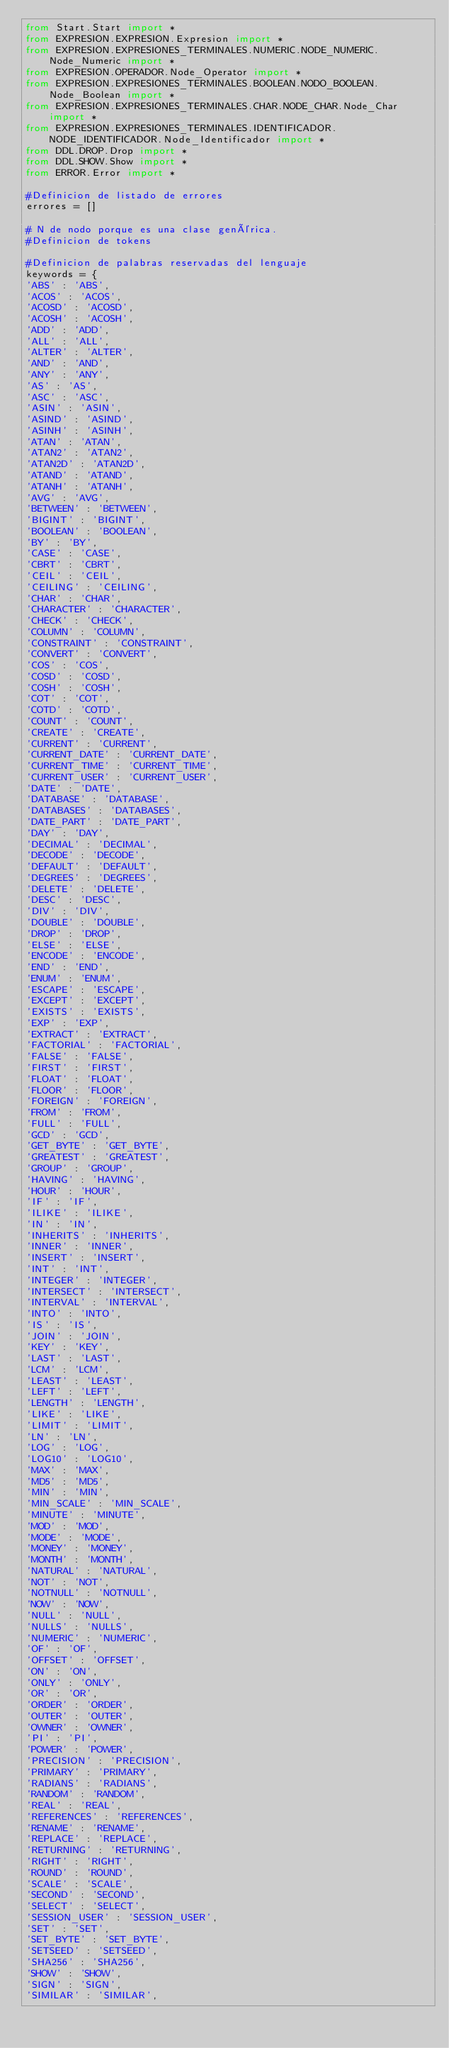Convert code to text. <code><loc_0><loc_0><loc_500><loc_500><_Python_>from Start.Start import * 
from EXPRESION.EXPRESION.Expresion import *
from EXPRESION.EXPRESIONES_TERMINALES.NUMERIC.NODE_NUMERIC.Node_Numeric import *
from EXPRESION.OPERADOR.Node_Operator import *
from EXPRESION.EXPRESIONES_TERMINALES.BOOLEAN.NODO_BOOLEAN.Node_Boolean import *
from EXPRESION.EXPRESIONES_TERMINALES.CHAR.NODE_CHAR.Node_Char import *
from EXPRESION.EXPRESIONES_TERMINALES.IDENTIFICADOR.NODE_IDENTIFICADOR.Node_Identificador import *
from DDL.DROP.Drop import *
from DDL.SHOW.Show import *
from ERROR.Error import *

#Definicion de listado de errores
errores = []

# N de nodo porque es una clase genérica.
#Definicion de tokens

#Definicion de palabras reservadas del lenguaje
keywords = {
'ABS' : 'ABS',
'ACOS' : 'ACOS',
'ACOSD' : 'ACOSD',
'ACOSH' : 'ACOSH',
'ADD' : 'ADD',
'ALL' : 'ALL',
'ALTER' : 'ALTER',
'AND' : 'AND',
'ANY' : 'ANY',
'AS' : 'AS',
'ASC' : 'ASC',
'ASIN' : 'ASIN',
'ASIND' : 'ASIND',
'ASINH' : 'ASINH',
'ATAN' : 'ATAN',
'ATAN2' : 'ATAN2',
'ATAN2D' : 'ATAN2D',
'ATAND' : 'ATAND',
'ATANH' : 'ATANH',
'AVG' : 'AVG',
'BETWEEN' : 'BETWEEN',
'BIGINT' : 'BIGINT',
'BOOLEAN' : 'BOOLEAN',
'BY' : 'BY',
'CASE' : 'CASE',
'CBRT' : 'CBRT',
'CEIL' : 'CEIL',
'CEILING' : 'CEILING',
'CHAR' : 'CHAR',
'CHARACTER' : 'CHARACTER',
'CHECK' : 'CHECK',
'COLUMN' : 'COLUMN',
'CONSTRAINT' : 'CONSTRAINT',
'CONVERT' : 'CONVERT',
'COS' : 'COS',
'COSD' : 'COSD',
'COSH' : 'COSH',
'COT' : 'COT',
'COTD' : 'COTD',
'COUNT' : 'COUNT',
'CREATE' : 'CREATE',
'CURRENT' : 'CURRENT',
'CURRENT_DATE' : 'CURRENT_DATE',
'CURRENT_TIME' : 'CURRENT_TIME',
'CURRENT_USER' : 'CURRENT_USER',
'DATE' : 'DATE',
'DATABASE' : 'DATABASE',
'DATABASES' : 'DATABASES',
'DATE_PART' : 'DATE_PART',
'DAY' : 'DAY',
'DECIMAL' : 'DECIMAL',
'DECODE' : 'DECODE',
'DEFAULT' : 'DEFAULT',
'DEGREES' : 'DEGREES',
'DELETE' : 'DELETE',
'DESC' : 'DESC',
'DIV' : 'DIV',
'DOUBLE' : 'DOUBLE',
'DROP' : 'DROP',
'ELSE' : 'ELSE',
'ENCODE' : 'ENCODE',
'END' : 'END',
'ENUM' : 'ENUM',
'ESCAPE' : 'ESCAPE',
'EXCEPT' : 'EXCEPT',
'EXISTS' : 'EXISTS',
'EXP' : 'EXP',
'EXTRACT' : 'EXTRACT',
'FACTORIAL' : 'FACTORIAL',
'FALSE' : 'FALSE',
'FIRST' : 'FIRST',
'FLOAT' : 'FLOAT',
'FLOOR' : 'FLOOR',
'FOREIGN' : 'FOREIGN',
'FROM' : 'FROM',
'FULL' : 'FULL',
'GCD' : 'GCD',
'GET_BYTE' : 'GET_BYTE',
'GREATEST' : 'GREATEST',
'GROUP' : 'GROUP',
'HAVING' : 'HAVING',
'HOUR' : 'HOUR',
'IF' : 'IF',
'ILIKE' : 'ILIKE',
'IN' : 'IN',
'INHERITS' : 'INHERITS',
'INNER' : 'INNER',
'INSERT' : 'INSERT',
'INT' : 'INT',
'INTEGER' : 'INTEGER',
'INTERSECT' : 'INTERSECT',
'INTERVAL' : 'INTERVAL',
'INTO' : 'INTO',
'IS' : 'IS',
'JOIN' : 'JOIN',
'KEY' : 'KEY',
'LAST' : 'LAST',
'LCM' : 'LCM',
'LEAST' : 'LEAST',
'LEFT' : 'LEFT',
'LENGTH' : 'LENGTH',
'LIKE' : 'LIKE',
'LIMIT' : 'LIMIT',
'LN' : 'LN',
'LOG' : 'LOG',
'LOG10' : 'LOG10',
'MAX' : 'MAX',
'MD5' : 'MD5',
'MIN' : 'MIN',
'MIN_SCALE' : 'MIN_SCALE',
'MINUTE' : 'MINUTE',
'MOD' : 'MOD',
'MODE' : 'MODE',
'MONEY' : 'MONEY',
'MONTH' : 'MONTH',
'NATURAL' : 'NATURAL',
'NOT' : 'NOT',
'NOTNULL' : 'NOTNULL',
'NOW' : 'NOW',
'NULL' : 'NULL',
'NULLS' : 'NULLS',
'NUMERIC' : 'NUMERIC',
'OF' : 'OF',
'OFFSET' : 'OFFSET',
'ON' : 'ON',
'ONLY' : 'ONLY',
'OR' : 'OR',
'ORDER' : 'ORDER',
'OUTER' : 'OUTER',
'OWNER' : 'OWNER',
'PI' : 'PI',
'POWER' : 'POWER',
'PRECISION' : 'PRECISION',
'PRIMARY' : 'PRIMARY',
'RADIANS' : 'RADIANS',
'RANDOM' : 'RANDOM',
'REAL' : 'REAL',
'REFERENCES' : 'REFERENCES',
'RENAME' : 'RENAME',
'REPLACE' : 'REPLACE',
'RETURNING' : 'RETURNING',
'RIGHT' : 'RIGHT',
'ROUND' : 'ROUND',
'SCALE' : 'SCALE',
'SECOND' : 'SECOND',
'SELECT' : 'SELECT',
'SESSION_USER' : 'SESSION_USER',
'SET' : 'SET',
'SET_BYTE' : 'SET_BYTE',
'SETSEED' : 'SETSEED',
'SHA256' : 'SHA256',
'SHOW' : 'SHOW',
'SIGN' : 'SIGN',
'SIMILAR' : 'SIMILAR',</code> 